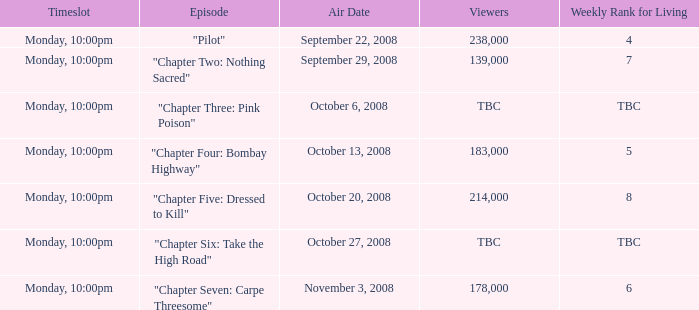How many viewers for the episode with the weekly rank for living of 4? 238000.0. 